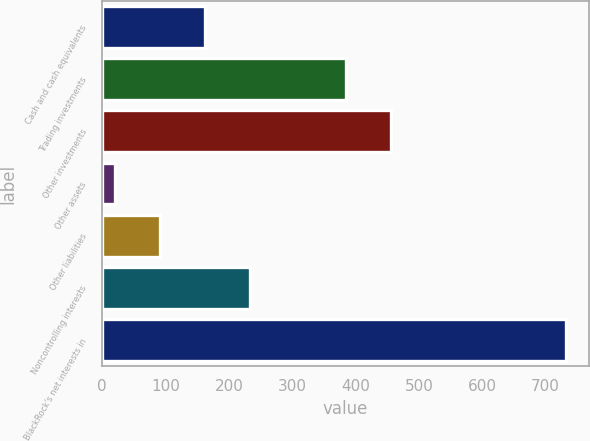Convert chart to OTSL. <chart><loc_0><loc_0><loc_500><loc_500><bar_chart><fcel>Cash and cash equivalents<fcel>Trading investments<fcel>Other investments<fcel>Other assets<fcel>Other liabilities<fcel>Noncontrolling interests<fcel>BlackRock's net interests in<nl><fcel>162.4<fcel>385<fcel>456.2<fcel>20<fcel>91.2<fcel>233.6<fcel>732<nl></chart> 